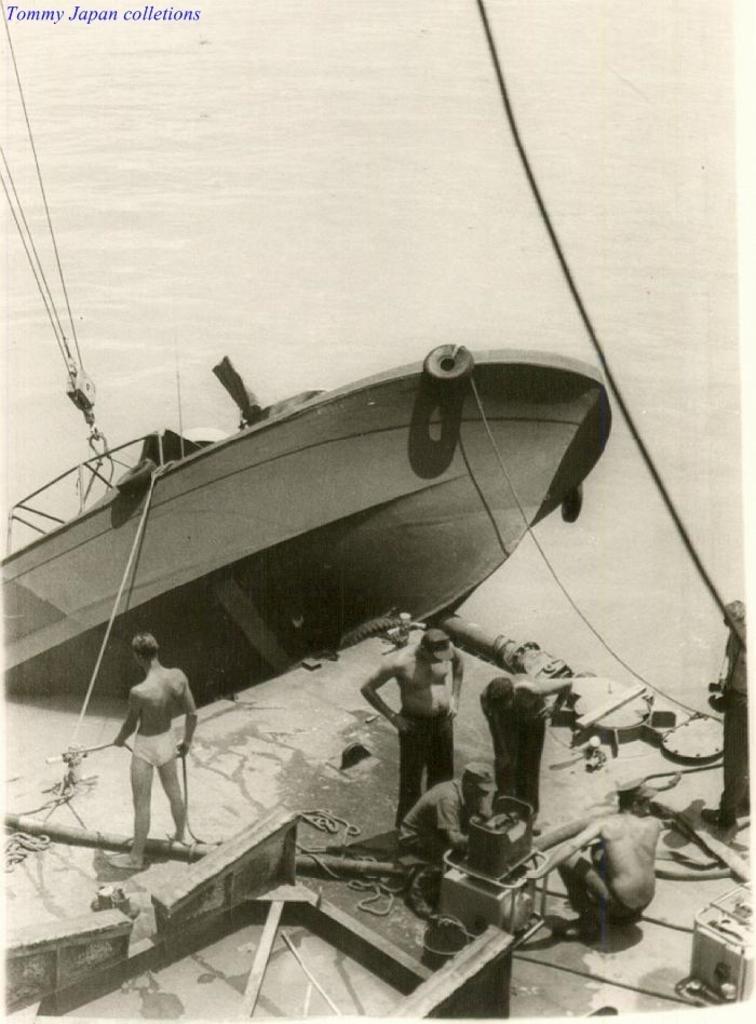Could you give a brief overview of what you see in this image? In this image I can see a picture of a boat, few persons on the platform and I see few things. I can also see few ropes. On the top left of this picture I can see the watermark. 